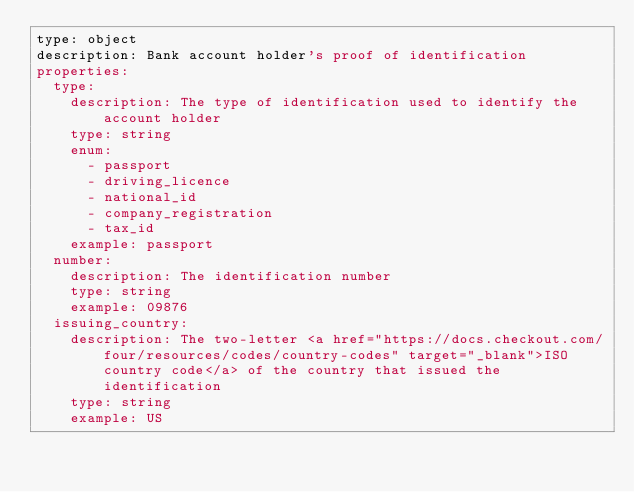Convert code to text. <code><loc_0><loc_0><loc_500><loc_500><_YAML_>type: object
description: Bank account holder's proof of identification
properties:
  type:
    description: The type of identification used to identify the account holder
    type: string
    enum: 
      - passport
      - driving_licence
      - national_id
      - company_registration
      - tax_id
    example: passport
  number:
    description: The identification number
    type: string
    example: 09876
  issuing_country:
    description: The two-letter <a href="https://docs.checkout.com/four/resources/codes/country-codes" target="_blank">ISO country code</a> of the country that issued the identification
    type: string
    example: US</code> 